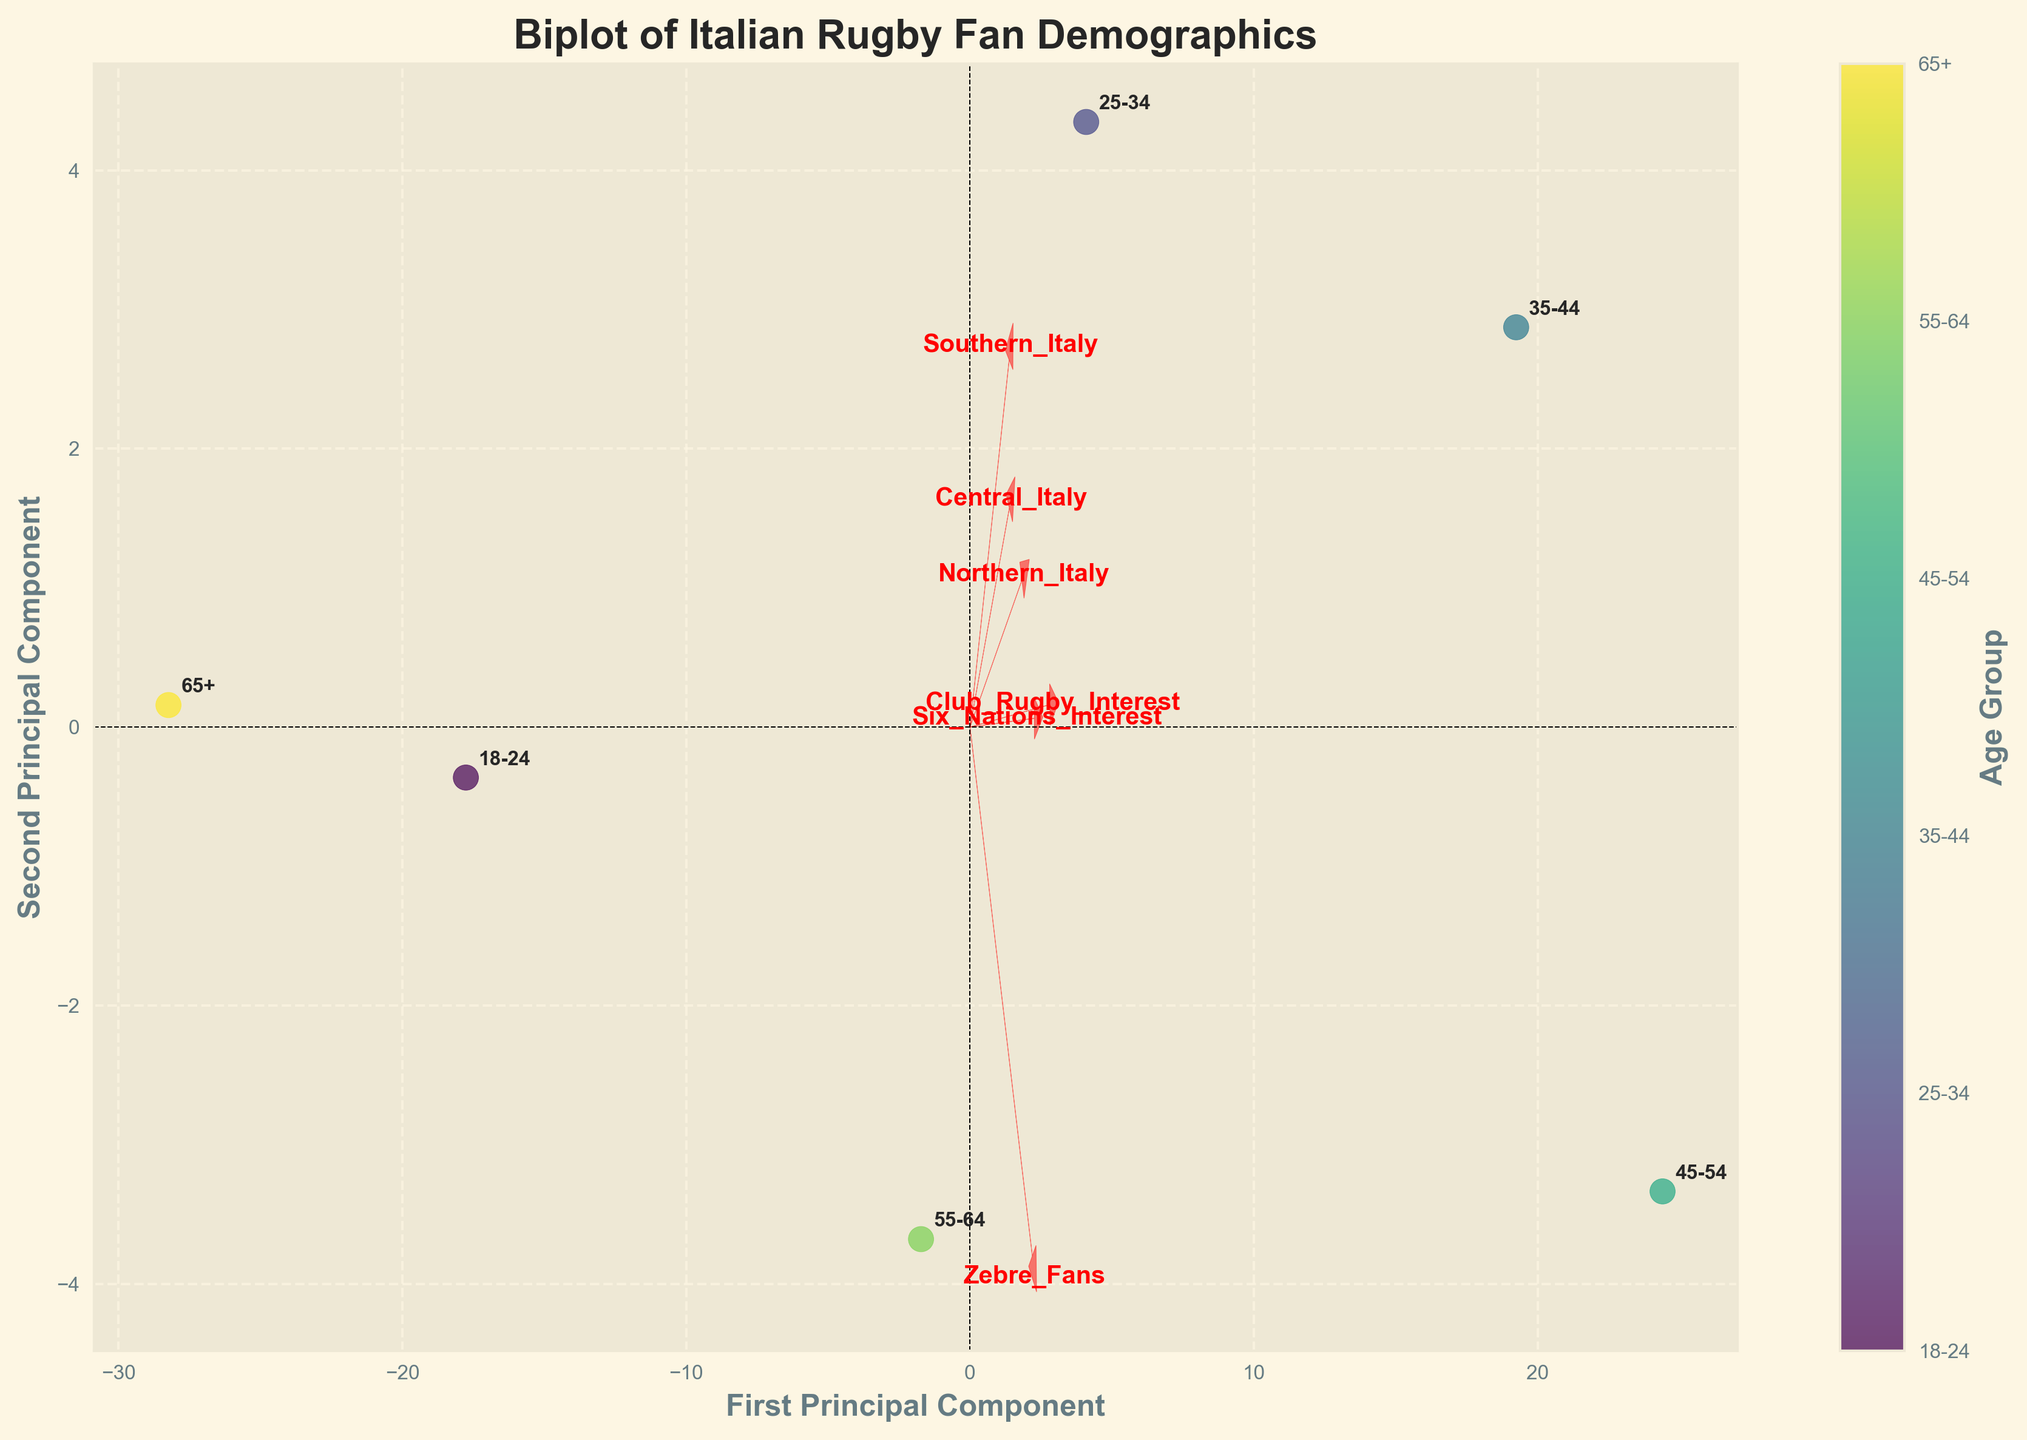How many age groups are represented in the figure? The figure's color bar displays labels representing different age groups. By counting these labels, we can determine the number of age groups. There are six labels representing different age groups: "18-24", "25-34", "35-44", "45-54", "55-64", and "65+".
Answer: 6 Which age group has the highest interest in Six Nations? The positioning of data points in the biplot along with the direction and length of the feature vector labeled "Six_Nations_Interest" indicate higher interest. The data point corresponding to "45-54" is the closest to this vector, suggesting it has the highest interest.
Answer: 45-54 Is the interest in Zebre matches higher in younger or older age groups? To determine this, we observe the alignment of age group data points relative to the "Zebre_Fans" vector. Younger age groups (e.g., "18-24" and "25-34") are positioned closer to this vector compared to older age groups (e.g., "55-64" and "65+"). This suggests greater interest among younger age groups.
Answer: Younger Which feature vector is the longest, indicating the strongest influence on the data? In a biplot, the length of a feature vector represents the extent of influence on the data. By comparing the lengths of all vectors, the vector labeled "Club_Rugby_Interest" appears to be the longest.
Answer: Club_Rugby_Interest Do Northern Italy fans have higher Zebre Fans or Club Rugby Interest? By comparing the proximity of the "Northern_Italy" data point to the vectors "Zebre_Fans" and "Club_Rugby_Interest," it is closer to "Club_Rugby_Interest." This indicates higher interest in Club Rugby compared to Zebre matches.
Answer: Club Rugby Interest How does the data point for the "35-44" age group relate to Six Nations Interest? To understand the relationship, we look at the position of the "35-44" age group relative to the "Six_Nations_Interest" vector. This data point is located quite close to the "Six_Nations_Interest," suggesting a relatively high level of interest in Six Nations among the "35-44" age group.
Answer: High interest What can be inferred about the "65+" age group's regional distribution? The biplot positions the "65+" data point closer to vectors for regional distribution (e.g., Northern, Central, Southern Italy). It is almost equidistant from the vectors for Southern and Northern Italy, suggesting a balanced distribution but lower overall compared to other age groups.
Answer: Balanced but lower distribution Which feature vector has the least influence on the "25-34" age group? By examining the distance of the "25-34" age group from all feature vectors, it is furthest from the "Southern_Italy" vector, indicating this feature has the least influence on the "25-34" age group.
Answer: Southern_Italy How do the "55-64" age group and "Zebre_Fans" correlate in the plot? One examines the alignment and distance of the "55-64" data point in relation to the "Zebre_Fans" vector. The "55-64" age group data point is moderately near the "Zebre_Fans" vector, suggesting some level of interest, though not as high as younger age groups.
Answer: Moderate interest 